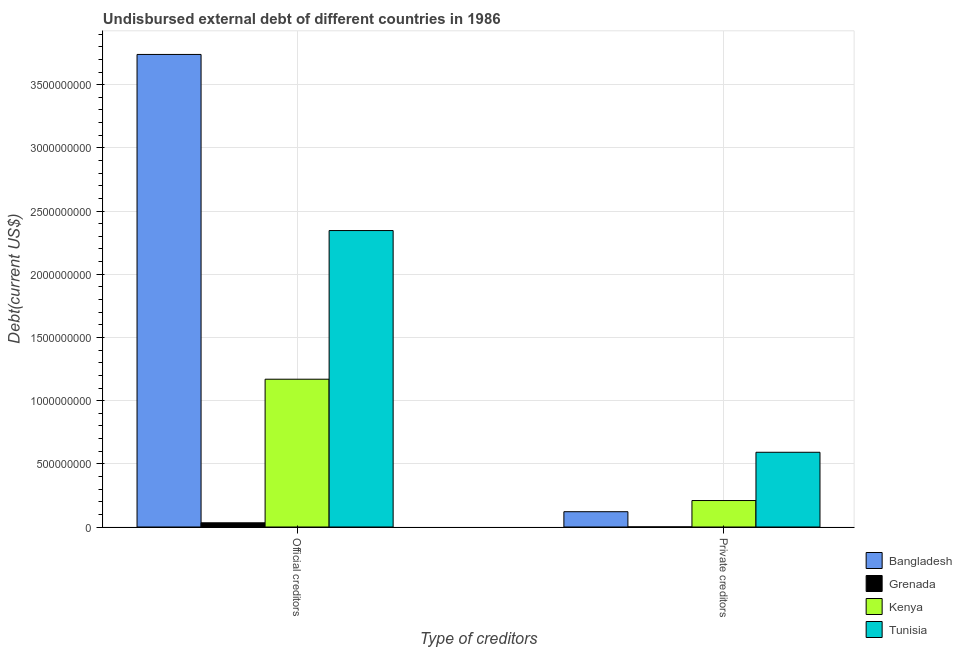Are the number of bars per tick equal to the number of legend labels?
Keep it short and to the point. Yes. How many bars are there on the 1st tick from the left?
Provide a succinct answer. 4. How many bars are there on the 1st tick from the right?
Offer a very short reply. 4. What is the label of the 1st group of bars from the left?
Keep it short and to the point. Official creditors. What is the undisbursed external debt of private creditors in Tunisia?
Offer a very short reply. 5.91e+08. Across all countries, what is the maximum undisbursed external debt of private creditors?
Offer a terse response. 5.91e+08. Across all countries, what is the minimum undisbursed external debt of private creditors?
Ensure brevity in your answer.  9.20e+05. In which country was the undisbursed external debt of private creditors maximum?
Your answer should be very brief. Tunisia. In which country was the undisbursed external debt of private creditors minimum?
Give a very brief answer. Grenada. What is the total undisbursed external debt of official creditors in the graph?
Your answer should be compact. 7.29e+09. What is the difference between the undisbursed external debt of private creditors in Tunisia and that in Bangladesh?
Make the answer very short. 4.70e+08. What is the difference between the undisbursed external debt of official creditors in Grenada and the undisbursed external debt of private creditors in Tunisia?
Keep it short and to the point. -5.58e+08. What is the average undisbursed external debt of official creditors per country?
Keep it short and to the point. 1.82e+09. What is the difference between the undisbursed external debt of private creditors and undisbursed external debt of official creditors in Tunisia?
Provide a short and direct response. -1.75e+09. In how many countries, is the undisbursed external debt of private creditors greater than 1500000000 US$?
Your response must be concise. 0. What is the ratio of the undisbursed external debt of official creditors in Grenada to that in Kenya?
Provide a short and direct response. 0.03. In how many countries, is the undisbursed external debt of private creditors greater than the average undisbursed external debt of private creditors taken over all countries?
Your answer should be compact. 1. What does the 2nd bar from the left in Official creditors represents?
Keep it short and to the point. Grenada. What does the 1st bar from the right in Private creditors represents?
Ensure brevity in your answer.  Tunisia. How many bars are there?
Ensure brevity in your answer.  8. Are all the bars in the graph horizontal?
Make the answer very short. No. What is the difference between two consecutive major ticks on the Y-axis?
Keep it short and to the point. 5.00e+08. Are the values on the major ticks of Y-axis written in scientific E-notation?
Make the answer very short. No. Does the graph contain grids?
Provide a short and direct response. Yes. How many legend labels are there?
Make the answer very short. 4. What is the title of the graph?
Give a very brief answer. Undisbursed external debt of different countries in 1986. What is the label or title of the X-axis?
Offer a very short reply. Type of creditors. What is the label or title of the Y-axis?
Provide a succinct answer. Debt(current US$). What is the Debt(current US$) in Bangladesh in Official creditors?
Your answer should be compact. 3.74e+09. What is the Debt(current US$) of Grenada in Official creditors?
Give a very brief answer. 3.33e+07. What is the Debt(current US$) in Kenya in Official creditors?
Make the answer very short. 1.17e+09. What is the Debt(current US$) of Tunisia in Official creditors?
Your response must be concise. 2.35e+09. What is the Debt(current US$) of Bangladesh in Private creditors?
Offer a terse response. 1.21e+08. What is the Debt(current US$) in Grenada in Private creditors?
Give a very brief answer. 9.20e+05. What is the Debt(current US$) in Kenya in Private creditors?
Provide a short and direct response. 2.09e+08. What is the Debt(current US$) in Tunisia in Private creditors?
Keep it short and to the point. 5.91e+08. Across all Type of creditors, what is the maximum Debt(current US$) in Bangladesh?
Provide a short and direct response. 3.74e+09. Across all Type of creditors, what is the maximum Debt(current US$) of Grenada?
Make the answer very short. 3.33e+07. Across all Type of creditors, what is the maximum Debt(current US$) in Kenya?
Your response must be concise. 1.17e+09. Across all Type of creditors, what is the maximum Debt(current US$) of Tunisia?
Ensure brevity in your answer.  2.35e+09. Across all Type of creditors, what is the minimum Debt(current US$) in Bangladesh?
Provide a succinct answer. 1.21e+08. Across all Type of creditors, what is the minimum Debt(current US$) of Grenada?
Provide a short and direct response. 9.20e+05. Across all Type of creditors, what is the minimum Debt(current US$) of Kenya?
Provide a short and direct response. 2.09e+08. Across all Type of creditors, what is the minimum Debt(current US$) of Tunisia?
Keep it short and to the point. 5.91e+08. What is the total Debt(current US$) of Bangladesh in the graph?
Your answer should be very brief. 3.86e+09. What is the total Debt(current US$) of Grenada in the graph?
Keep it short and to the point. 3.42e+07. What is the total Debt(current US$) of Kenya in the graph?
Offer a very short reply. 1.38e+09. What is the total Debt(current US$) in Tunisia in the graph?
Provide a short and direct response. 2.94e+09. What is the difference between the Debt(current US$) in Bangladesh in Official creditors and that in Private creditors?
Offer a very short reply. 3.62e+09. What is the difference between the Debt(current US$) of Grenada in Official creditors and that in Private creditors?
Your answer should be very brief. 3.24e+07. What is the difference between the Debt(current US$) of Kenya in Official creditors and that in Private creditors?
Your answer should be very brief. 9.60e+08. What is the difference between the Debt(current US$) in Tunisia in Official creditors and that in Private creditors?
Your answer should be compact. 1.75e+09. What is the difference between the Debt(current US$) in Bangladesh in Official creditors and the Debt(current US$) in Grenada in Private creditors?
Give a very brief answer. 3.74e+09. What is the difference between the Debt(current US$) in Bangladesh in Official creditors and the Debt(current US$) in Kenya in Private creditors?
Offer a very short reply. 3.53e+09. What is the difference between the Debt(current US$) of Bangladesh in Official creditors and the Debt(current US$) of Tunisia in Private creditors?
Offer a very short reply. 3.15e+09. What is the difference between the Debt(current US$) in Grenada in Official creditors and the Debt(current US$) in Kenya in Private creditors?
Make the answer very short. -1.76e+08. What is the difference between the Debt(current US$) in Grenada in Official creditors and the Debt(current US$) in Tunisia in Private creditors?
Make the answer very short. -5.58e+08. What is the difference between the Debt(current US$) in Kenya in Official creditors and the Debt(current US$) in Tunisia in Private creditors?
Keep it short and to the point. 5.78e+08. What is the average Debt(current US$) in Bangladesh per Type of creditors?
Your answer should be very brief. 1.93e+09. What is the average Debt(current US$) of Grenada per Type of creditors?
Ensure brevity in your answer.  1.71e+07. What is the average Debt(current US$) in Kenya per Type of creditors?
Provide a succinct answer. 6.90e+08. What is the average Debt(current US$) in Tunisia per Type of creditors?
Your answer should be very brief. 1.47e+09. What is the difference between the Debt(current US$) in Bangladesh and Debt(current US$) in Grenada in Official creditors?
Make the answer very short. 3.71e+09. What is the difference between the Debt(current US$) in Bangladesh and Debt(current US$) in Kenya in Official creditors?
Make the answer very short. 2.57e+09. What is the difference between the Debt(current US$) in Bangladesh and Debt(current US$) in Tunisia in Official creditors?
Your answer should be compact. 1.39e+09. What is the difference between the Debt(current US$) of Grenada and Debt(current US$) of Kenya in Official creditors?
Make the answer very short. -1.14e+09. What is the difference between the Debt(current US$) of Grenada and Debt(current US$) of Tunisia in Official creditors?
Your answer should be very brief. -2.31e+09. What is the difference between the Debt(current US$) in Kenya and Debt(current US$) in Tunisia in Official creditors?
Give a very brief answer. -1.18e+09. What is the difference between the Debt(current US$) in Bangladesh and Debt(current US$) in Grenada in Private creditors?
Your answer should be compact. 1.20e+08. What is the difference between the Debt(current US$) in Bangladesh and Debt(current US$) in Kenya in Private creditors?
Your response must be concise. -8.85e+07. What is the difference between the Debt(current US$) in Bangladesh and Debt(current US$) in Tunisia in Private creditors?
Provide a succinct answer. -4.70e+08. What is the difference between the Debt(current US$) in Grenada and Debt(current US$) in Kenya in Private creditors?
Keep it short and to the point. -2.09e+08. What is the difference between the Debt(current US$) in Grenada and Debt(current US$) in Tunisia in Private creditors?
Make the answer very short. -5.90e+08. What is the difference between the Debt(current US$) of Kenya and Debt(current US$) of Tunisia in Private creditors?
Make the answer very short. -3.82e+08. What is the ratio of the Debt(current US$) of Bangladesh in Official creditors to that in Private creditors?
Offer a terse response. 30.9. What is the ratio of the Debt(current US$) of Grenada in Official creditors to that in Private creditors?
Offer a terse response. 36.21. What is the ratio of the Debt(current US$) in Kenya in Official creditors to that in Private creditors?
Make the answer very short. 5.58. What is the ratio of the Debt(current US$) of Tunisia in Official creditors to that in Private creditors?
Ensure brevity in your answer.  3.97. What is the difference between the highest and the second highest Debt(current US$) in Bangladesh?
Your answer should be compact. 3.62e+09. What is the difference between the highest and the second highest Debt(current US$) in Grenada?
Your answer should be very brief. 3.24e+07. What is the difference between the highest and the second highest Debt(current US$) of Kenya?
Keep it short and to the point. 9.60e+08. What is the difference between the highest and the second highest Debt(current US$) of Tunisia?
Ensure brevity in your answer.  1.75e+09. What is the difference between the highest and the lowest Debt(current US$) of Bangladesh?
Keep it short and to the point. 3.62e+09. What is the difference between the highest and the lowest Debt(current US$) of Grenada?
Your response must be concise. 3.24e+07. What is the difference between the highest and the lowest Debt(current US$) in Kenya?
Your response must be concise. 9.60e+08. What is the difference between the highest and the lowest Debt(current US$) of Tunisia?
Give a very brief answer. 1.75e+09. 